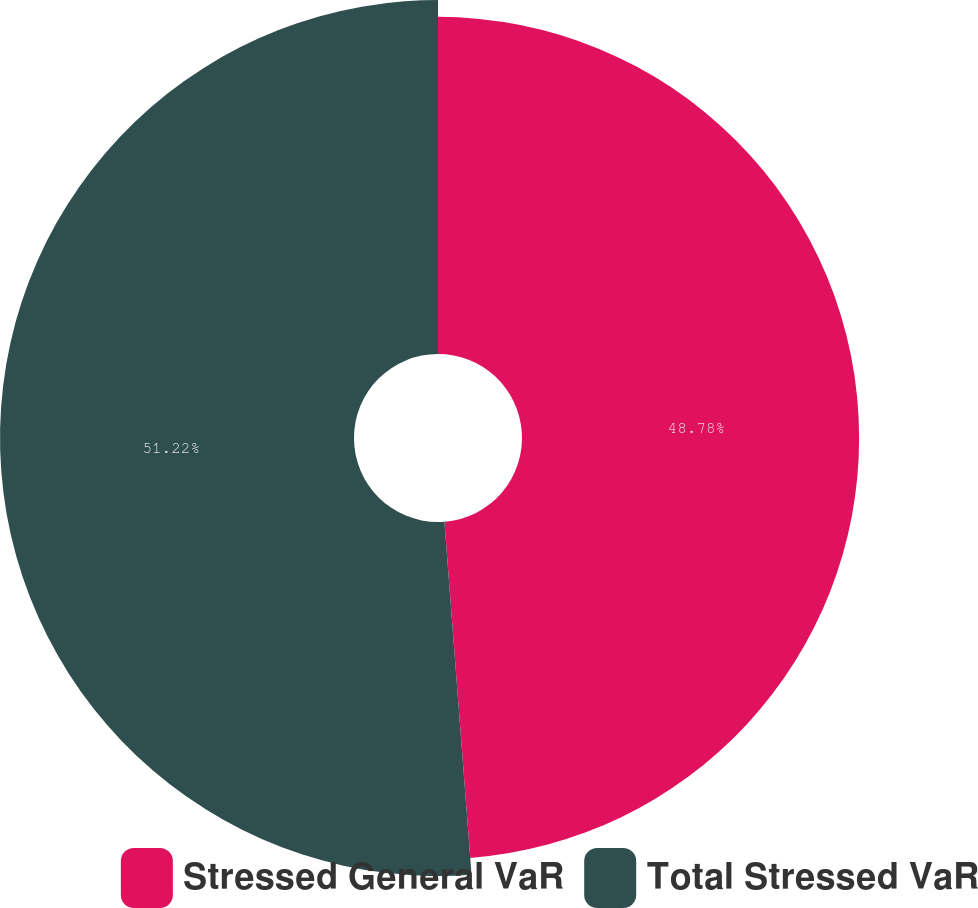Convert chart. <chart><loc_0><loc_0><loc_500><loc_500><pie_chart><fcel>Stressed General VaR<fcel>Total Stressed VaR<nl><fcel>48.78%<fcel>51.22%<nl></chart> 